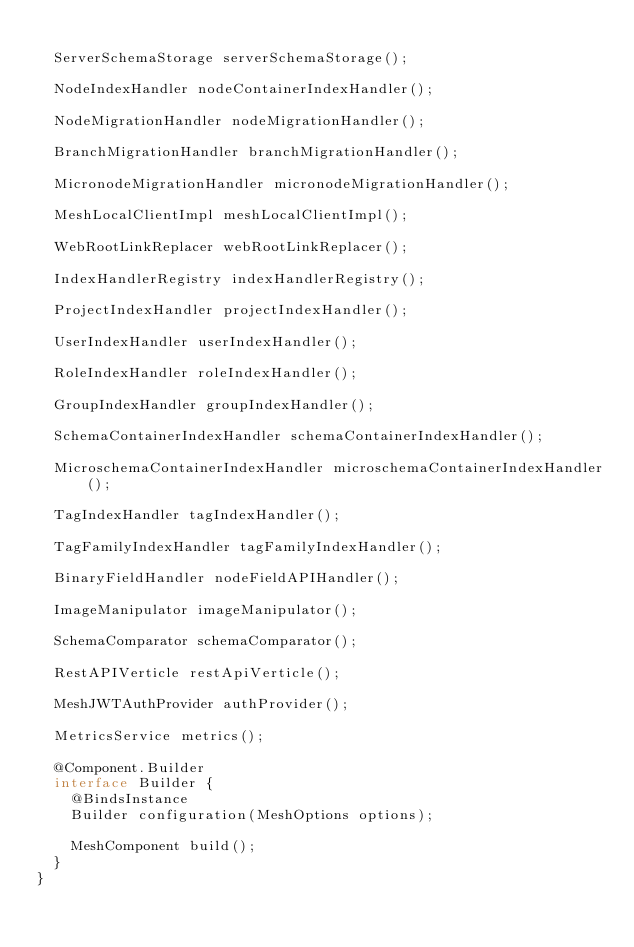Convert code to text. <code><loc_0><loc_0><loc_500><loc_500><_Java_>
	ServerSchemaStorage serverSchemaStorage();

	NodeIndexHandler nodeContainerIndexHandler();

	NodeMigrationHandler nodeMigrationHandler();

	BranchMigrationHandler branchMigrationHandler();

	MicronodeMigrationHandler micronodeMigrationHandler();

	MeshLocalClientImpl meshLocalClientImpl();

	WebRootLinkReplacer webRootLinkReplacer();

	IndexHandlerRegistry indexHandlerRegistry();

	ProjectIndexHandler projectIndexHandler();

	UserIndexHandler userIndexHandler();

	RoleIndexHandler roleIndexHandler();

	GroupIndexHandler groupIndexHandler();

	SchemaContainerIndexHandler schemaContainerIndexHandler();

	MicroschemaContainerIndexHandler microschemaContainerIndexHandler();

	TagIndexHandler tagIndexHandler();

	TagFamilyIndexHandler tagFamilyIndexHandler();

	BinaryFieldHandler nodeFieldAPIHandler();

	ImageManipulator imageManipulator();

	SchemaComparator schemaComparator();

	RestAPIVerticle restApiVerticle();

	MeshJWTAuthProvider authProvider();

	MetricsService metrics();

	@Component.Builder
	interface Builder {
		@BindsInstance
		Builder configuration(MeshOptions options);

		MeshComponent build();
	}
}
</code> 